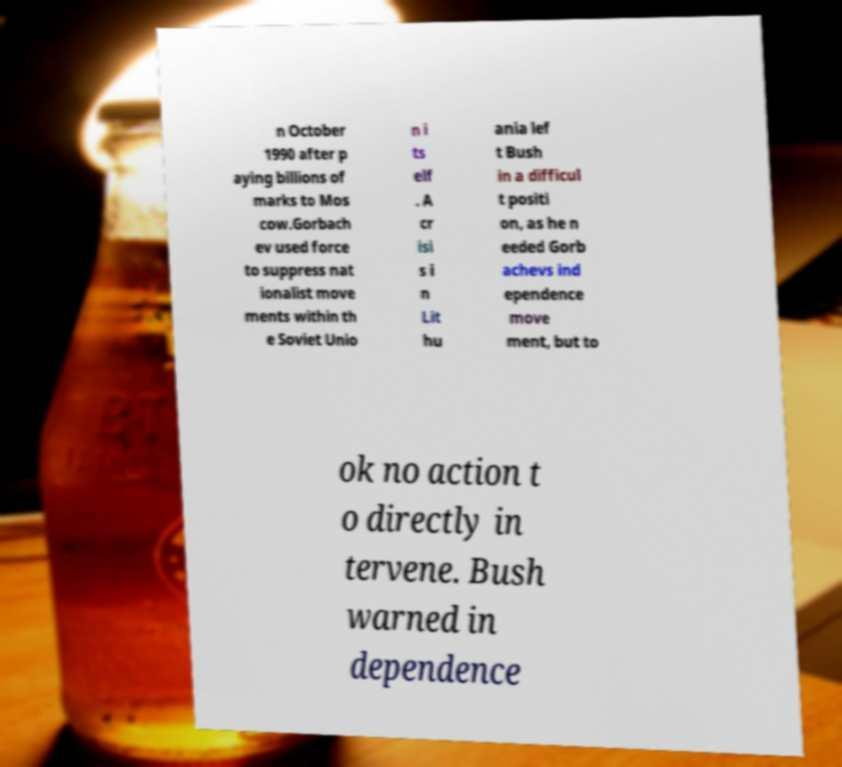Can you read and provide the text displayed in the image?This photo seems to have some interesting text. Can you extract and type it out for me? n October 1990 after p aying billions of marks to Mos cow.Gorbach ev used force to suppress nat ionalist move ments within th e Soviet Unio n i ts elf . A cr isi s i n Lit hu ania lef t Bush in a difficul t positi on, as he n eeded Gorb achevs ind ependence move ment, but to ok no action t o directly in tervene. Bush warned in dependence 